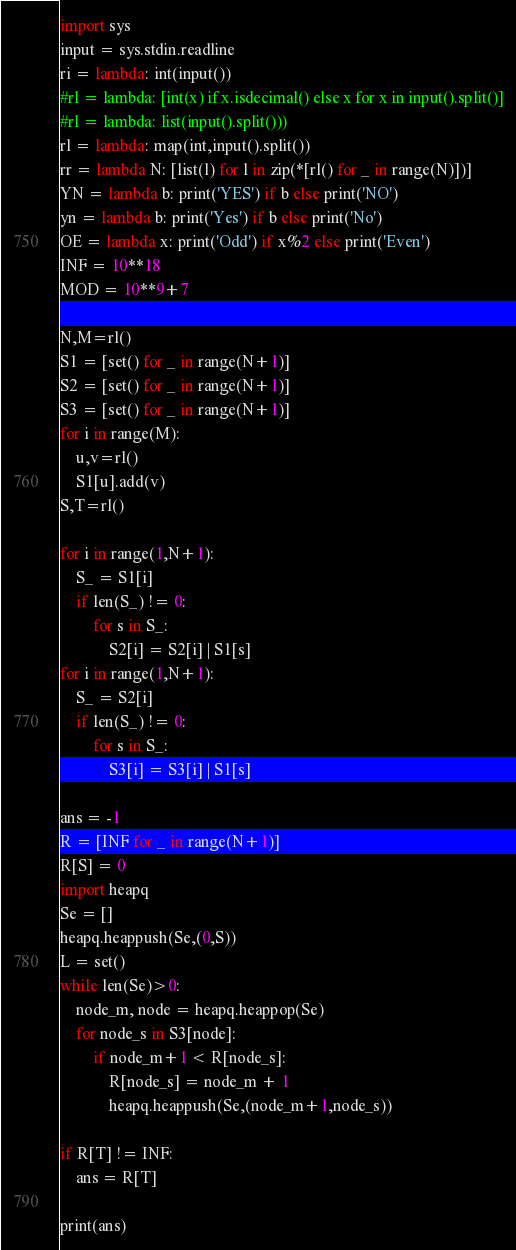Convert code to text. <code><loc_0><loc_0><loc_500><loc_500><_Python_>import sys
input = sys.stdin.readline
ri = lambda: int(input())
#rl = lambda: [int(x) if x.isdecimal() else x for x in input().split()]
#rl = lambda: list(input().split()))
rl = lambda: map(int,input().split())
rr = lambda N: [list(l) for l in zip(*[rl() for _ in range(N)])]
YN = lambda b: print('YES') if b else print('NO')
yn = lambda b: print('Yes') if b else print('No')
OE = lambda x: print('Odd') if x%2 else print('Even')
INF = 10**18
MOD = 10**9+7

N,M=rl()
S1 = [set() for _ in range(N+1)]
S2 = [set() for _ in range(N+1)]
S3 = [set() for _ in range(N+1)]
for i in range(M):
    u,v=rl()
    S1[u].add(v)
S,T=rl()

for i in range(1,N+1):
    S_ = S1[i]
    if len(S_) != 0:
        for s in S_:
            S2[i] = S2[i] | S1[s]
for i in range(1,N+1):
    S_ = S2[i]
    if len(S_) != 0:
        for s in S_:
            S3[i] = S3[i] | S1[s]

ans = -1
R = [INF for _ in range(N+1)]
R[S] = 0
import heapq
Se = []
heapq.heappush(Se,(0,S))
L = set()
while len(Se)>0:
    node_m, node = heapq.heappop(Se) 
    for node_s in S3[node]:
        if node_m+1 < R[node_s]:
            R[node_s] = node_m + 1
            heapq.heappush(Se,(node_m+1,node_s))

if R[T] != INF:
    ans = R[T]

print(ans)
</code> 